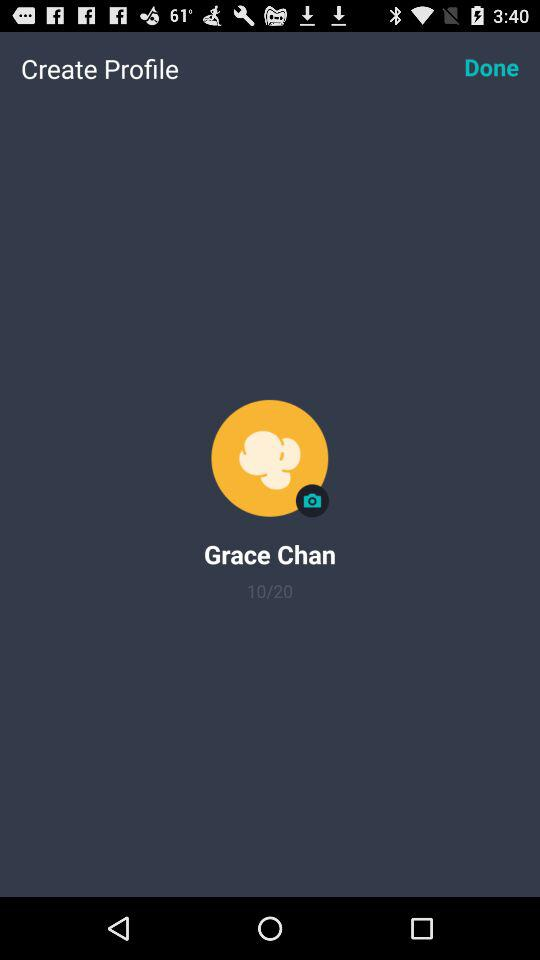What is the user name? The user name is Grace Chan. 